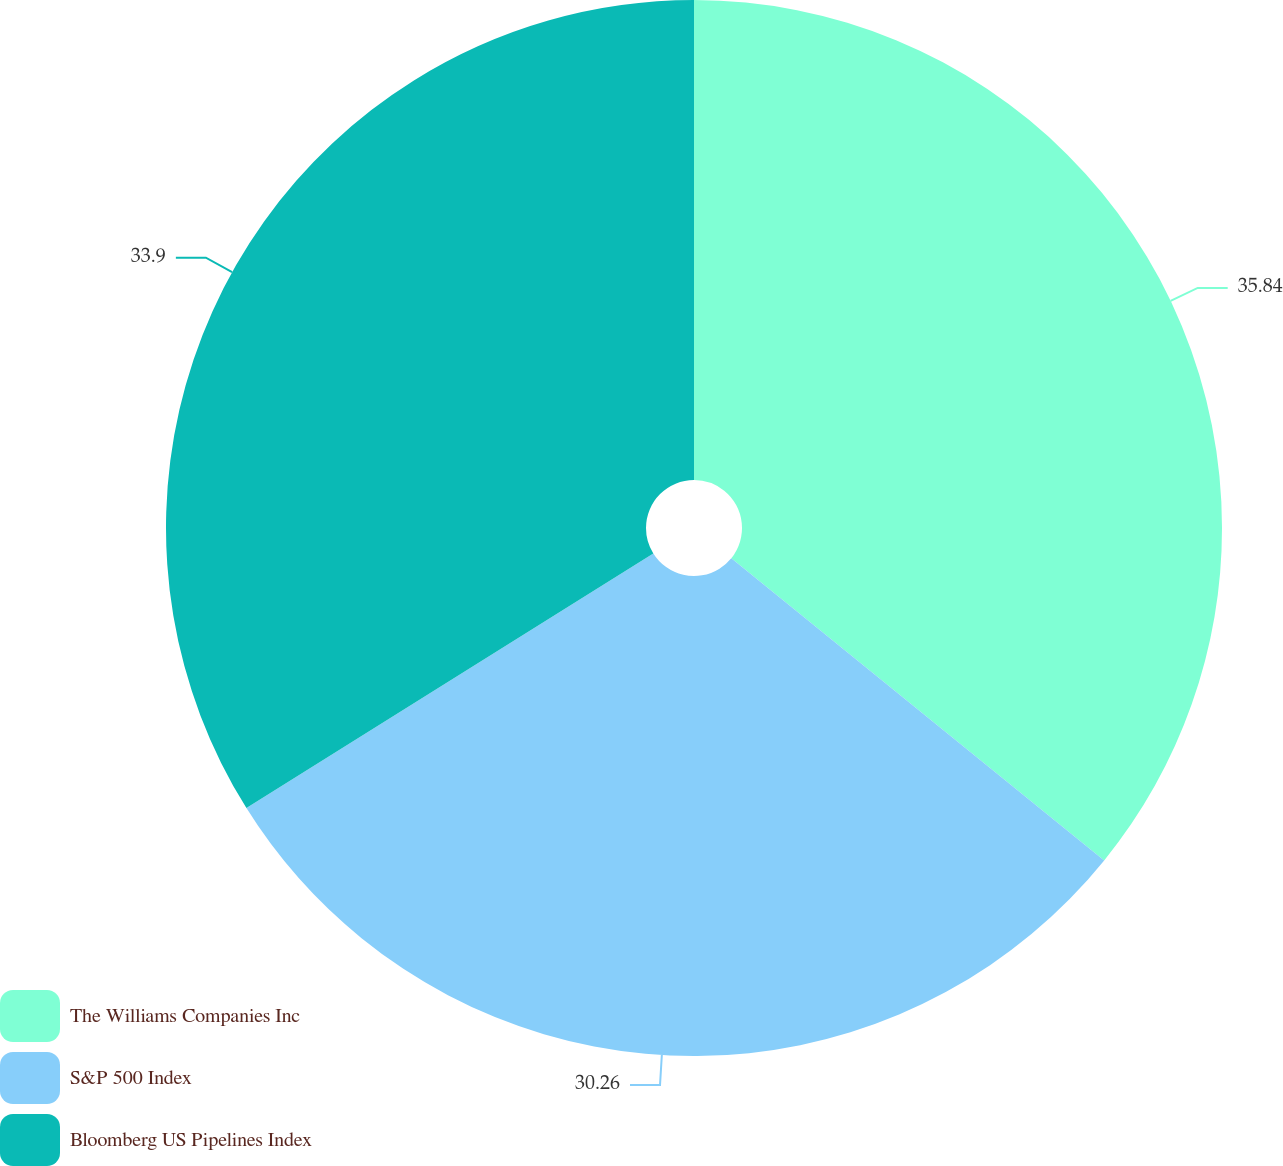Convert chart. <chart><loc_0><loc_0><loc_500><loc_500><pie_chart><fcel>The Williams Companies Inc<fcel>S&P 500 Index<fcel>Bloomberg US Pipelines Index<nl><fcel>35.84%<fcel>30.26%<fcel>33.9%<nl></chart> 